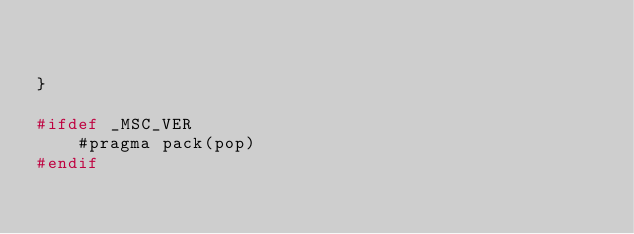Convert code to text. <code><loc_0><loc_0><loc_500><loc_500><_C++_>

}

#ifdef _MSC_VER
	#pragma pack(pop)
#endif
</code> 